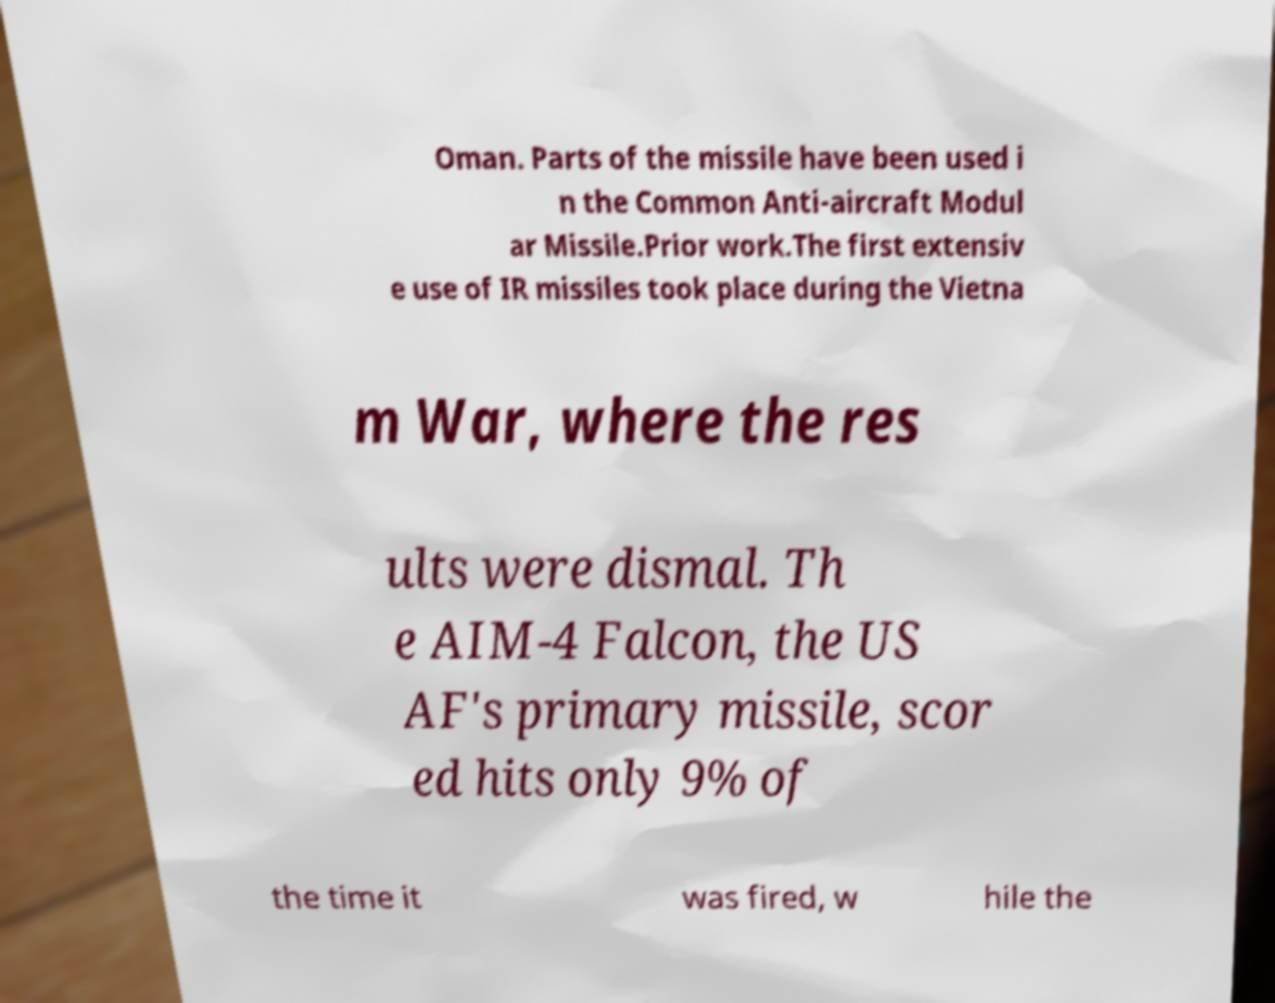Please read and relay the text visible in this image. What does it say? Oman. Parts of the missile have been used i n the Common Anti-aircraft Modul ar Missile.Prior work.The first extensiv e use of IR missiles took place during the Vietna m War, where the res ults were dismal. Th e AIM-4 Falcon, the US AF's primary missile, scor ed hits only 9% of the time it was fired, w hile the 